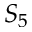<formula> <loc_0><loc_0><loc_500><loc_500>S _ { 5 }</formula> 